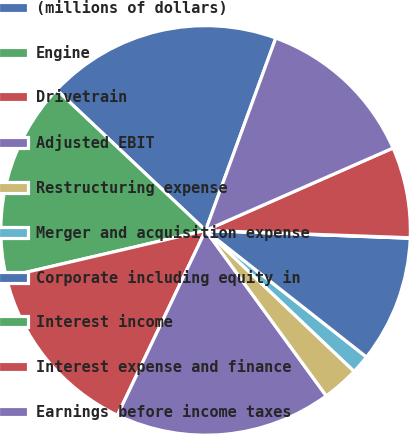Convert chart to OTSL. <chart><loc_0><loc_0><loc_500><loc_500><pie_chart><fcel>(millions of dollars)<fcel>Engine<fcel>Drivetrain<fcel>Adjusted EBIT<fcel>Restructuring expense<fcel>Merger and acquisition expense<fcel>Corporate including equity in<fcel>Interest income<fcel>Interest expense and finance<fcel>Earnings before income taxes<nl><fcel>18.53%<fcel>15.69%<fcel>14.27%<fcel>17.11%<fcel>2.89%<fcel>1.47%<fcel>10.0%<fcel>0.04%<fcel>7.16%<fcel>12.84%<nl></chart> 